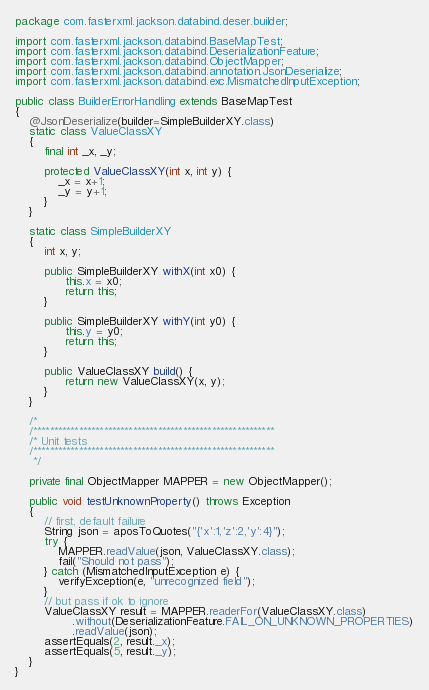Convert code to text. <code><loc_0><loc_0><loc_500><loc_500><_Java_>package com.fasterxml.jackson.databind.deser.builder;

import com.fasterxml.jackson.databind.BaseMapTest;
import com.fasterxml.jackson.databind.DeserializationFeature;
import com.fasterxml.jackson.databind.ObjectMapper;
import com.fasterxml.jackson.databind.annotation.JsonDeserialize;
import com.fasterxml.jackson.databind.exc.MismatchedInputException;

public class BuilderErrorHandling extends BaseMapTest
{
    @JsonDeserialize(builder=SimpleBuilderXY.class)
    static class ValueClassXY
    {
        final int _x, _y;

        protected ValueClassXY(int x, int y) {
            _x = x+1;
            _y = y+1;
        }
    }

    static class SimpleBuilderXY
    {
        int x, y;
     
        public SimpleBuilderXY withX(int x0) {
              this.x = x0;
              return this;
        }

        public SimpleBuilderXY withY(int y0) {
              this.y = y0;
              return this;
        }

        public ValueClassXY build() {
              return new ValueClassXY(x, y);
        }
    }

    /*
    /**********************************************************
    /* Unit tests
    /**********************************************************
     */

    private final ObjectMapper MAPPER = new ObjectMapper();
    
    public void testUnknownProperty() throws Exception
    {
        // first, default failure
        String json = aposToQuotes("{'x':1,'z':2,'y':4}");
        try {
            MAPPER.readValue(json, ValueClassXY.class);
            fail("Should not pass");
        } catch (MismatchedInputException e) {
            verifyException(e, "unrecognized field");
        }
        // but pass if ok to ignore
        ValueClassXY result = MAPPER.readerFor(ValueClassXY.class)
                .without(DeserializationFeature.FAIL_ON_UNKNOWN_PROPERTIES)
                .readValue(json);
        assertEquals(2, result._x);
        assertEquals(5, result._y);
    }
}
</code> 